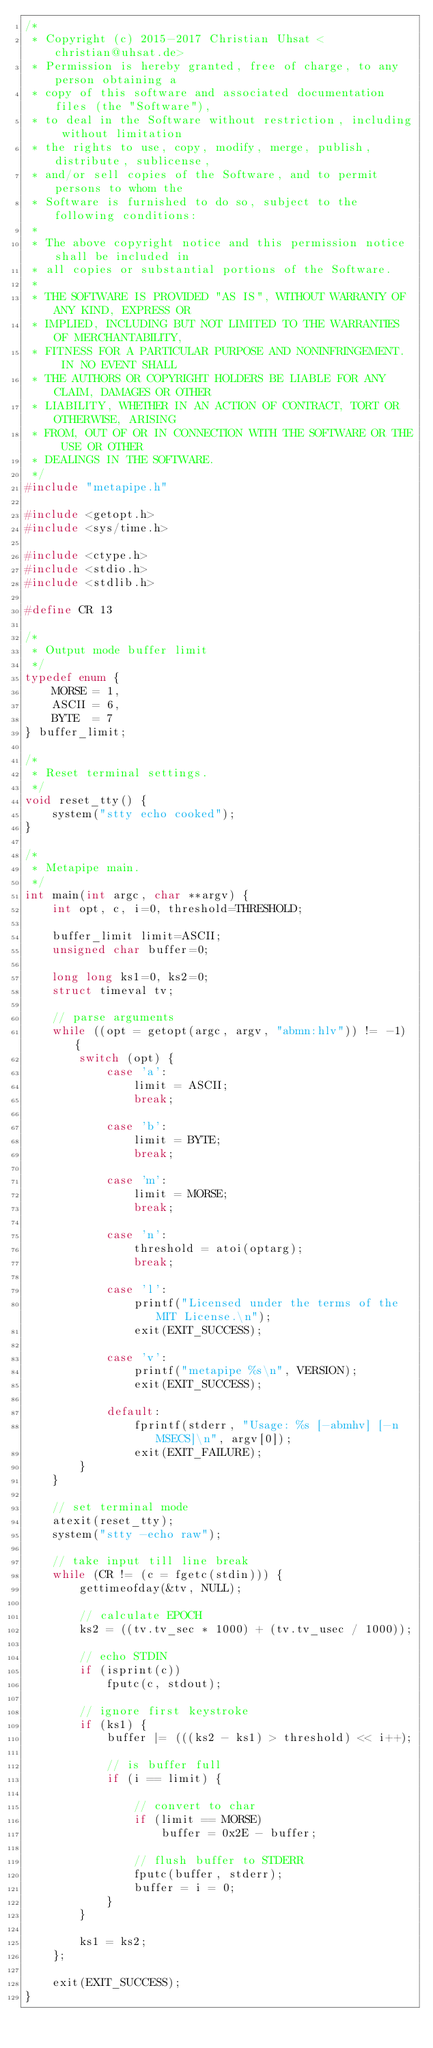<code> <loc_0><loc_0><loc_500><loc_500><_C_>/*
 * Copyright (c) 2015-2017 Christian Uhsat <christian@uhsat.de>
 * Permission is hereby granted, free of charge, to any person obtaining a
 * copy of this software and associated documentation files (the "Software"),
 * to deal in the Software without restriction, including without limitation
 * the rights to use, copy, modify, merge, publish, distribute, sublicense,
 * and/or sell copies of the Software, and to permit persons to whom the
 * Software is furnished to do so, subject to the following conditions:
 *
 * The above copyright notice and this permission notice shall be included in
 * all copies or substantial portions of the Software.
 *
 * THE SOFTWARE IS PROVIDED "AS IS", WITHOUT WARRANTY OF ANY KIND, EXPRESS OR
 * IMPLIED, INCLUDING BUT NOT LIMITED TO THE WARRANTIES OF MERCHANTABILITY,
 * FITNESS FOR A PARTICULAR PURPOSE AND NONINFRINGEMENT.  IN NO EVENT SHALL
 * THE AUTHORS OR COPYRIGHT HOLDERS BE LIABLE FOR ANY CLAIM, DAMAGES OR OTHER
 * LIABILITY, WHETHER IN AN ACTION OF CONTRACT, TORT OR OTHERWISE, ARISING
 * FROM, OUT OF OR IN CONNECTION WITH THE SOFTWARE OR THE USE OR OTHER
 * DEALINGS IN THE SOFTWARE.
 */
#include "metapipe.h"

#include <getopt.h>
#include <sys/time.h>

#include <ctype.h>
#include <stdio.h>
#include <stdlib.h>

#define CR 13

/*
 * Output mode buffer limit
 */
typedef enum {
    MORSE = 1,
    ASCII = 6,
    BYTE  = 7
} buffer_limit;

/*
 * Reset terminal settings.
 */
void reset_tty() {
    system("stty echo cooked");
}

/*
 * Metapipe main.
 */
int main(int argc, char **argv) {
    int opt, c, i=0, threshold=THRESHOLD;

    buffer_limit limit=ASCII;
    unsigned char buffer=0;

    long long ks1=0, ks2=0;
    struct timeval tv;

    // parse arguments
    while ((opt = getopt(argc, argv, "abmn:hlv")) != -1) {
        switch (opt) {
            case 'a':
                limit = ASCII;
                break;

            case 'b':
                limit = BYTE;
                break;

            case 'm':
                limit = MORSE;
                break;

            case 'n':
                threshold = atoi(optarg);
                break;

            case 'l':
                printf("Licensed under the terms of the MIT License.\n");
                exit(EXIT_SUCCESS);

            case 'v':
                printf("metapipe %s\n", VERSION);
                exit(EXIT_SUCCESS);

            default:
                fprintf(stderr, "Usage: %s [-abmhv] [-n MSECS]\n", argv[0]);
                exit(EXIT_FAILURE);
        }
    }

    // set terminal mode
    atexit(reset_tty);
    system("stty -echo raw");

    // take input till line break
    while (CR != (c = fgetc(stdin))) {
        gettimeofday(&tv, NULL);

        // calculate EPOCH
        ks2 = ((tv.tv_sec * 1000) + (tv.tv_usec / 1000));

        // echo STDIN
        if (isprint(c))
            fputc(c, stdout);

        // ignore first keystroke
        if (ks1) {
            buffer |= (((ks2 - ks1) > threshold) << i++);

            // is buffer full
            if (i == limit) {

                // convert to char
                if (limit == MORSE)
                    buffer = 0x2E - buffer;

                // flush buffer to STDERR
                fputc(buffer, stderr);
                buffer = i = 0;
            }
        }

        ks1 = ks2;
    };

    exit(EXIT_SUCCESS);
}
</code> 